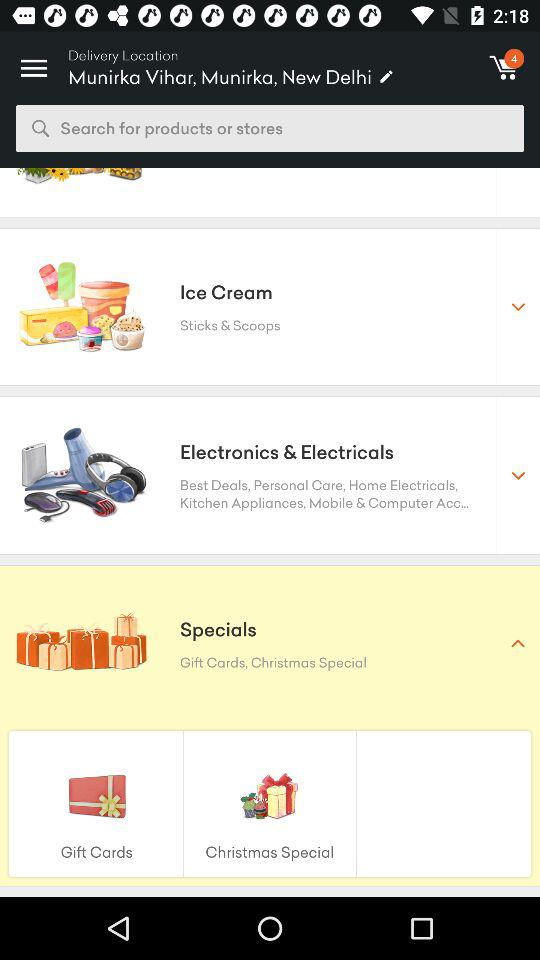What is the delivery location? The delivery location is Munirka Vihar, Munirka, New Delhi. 